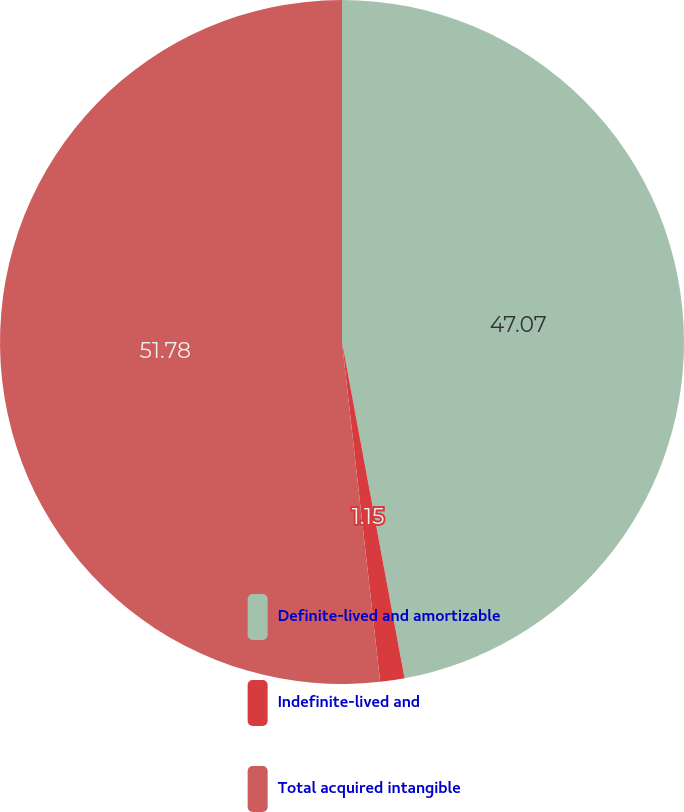Convert chart. <chart><loc_0><loc_0><loc_500><loc_500><pie_chart><fcel>Definite-lived and amortizable<fcel>Indefinite-lived and<fcel>Total acquired intangible<nl><fcel>47.07%<fcel>1.15%<fcel>51.78%<nl></chart> 